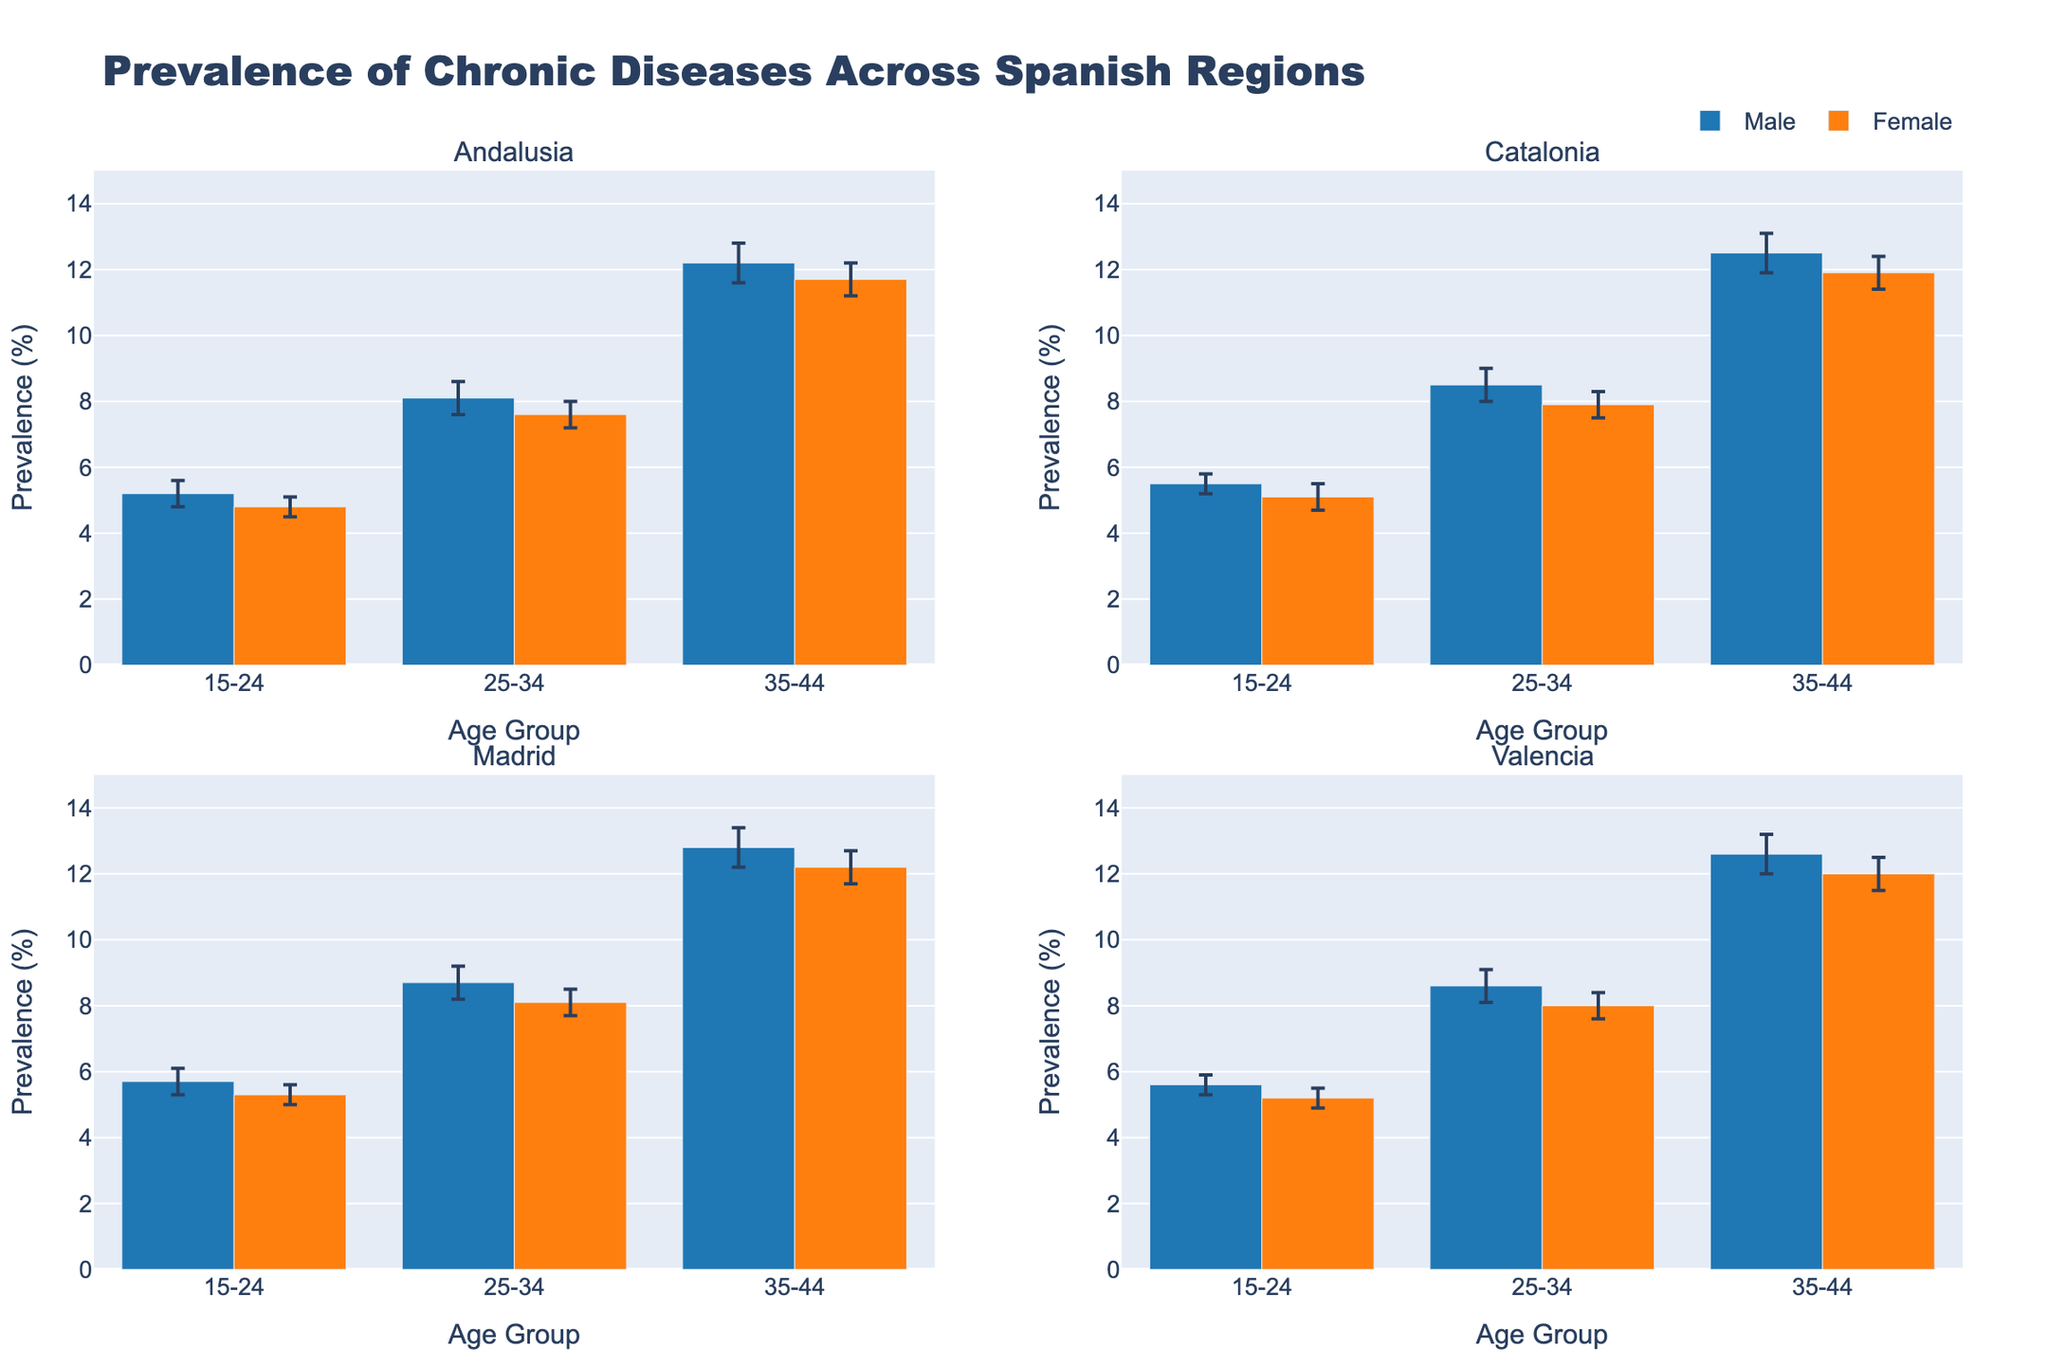What's the title of the figure? The title is displayed at the top center of the figure.
Answer: Prevalence of Chronic Diseases Across Spanish Regions Which age group has the highest prevalence of chronic diseases in Andalusia for males? We locate Andalusia in the top-left subplot, identify the blue bars, and see that the 35-44 age group has the highest value.
Answer: 35-44 What is the prevalence of chronic diseases for females aged 25-34 in Madrid? In the Madrid subplot (bottom-left), look for the orange bar corresponding to 25-34 age group and read its height.
Answer: 8.1% How does the prevalence of chronic diseases among males aged 15-24 in Catalonia compare to those in Valencia? Compare the heights of the blue bars for the 15-24 age group in the Catalonia (top-right) and Valencia (bottom-right) subplots.
Answer: Catalonia has a higher prevalence (5.5% vs. 5.6%) Which region has the smallest error bar for males aged 35-44? Look across all subplots at the blue bars for 35-44 age group and compare the lengths of the error bars.
Answer: All regions have the same error bar length (0.6%) What is the difference in chronic disease prevalence between males and females aged 35-44 in Valencia? In the Valencia subplot (bottom-right), subtract the height of the orange bar from the blue bar for the 35-44 age group.
Answer: 0.6% (12.6% - 12%) Which gender generally shows higher prevalence rates across age groups in any region? By inspecting the bar heights in all subplots, we observe whether blue (males) or orange (females) bars are generally taller.
Answer: Males In which region is the prevalence for females aged 25-34 higher than for males in the same age group? Check each subplot for the 25-34 age group to see if the orange bar is taller than the blue bar.
Answer: None Calculate the average prevalence of chronic diseases for all age groups in Catalonia for males. Add the heights of the blue bars in Catalonia subplot and divide by the number of age groups (3). (5.5 + 8.5 + 12.5) / 3
Answer: 8.83% Are the error bars for chronic disease prevalence consistent across regions for any age group? Check if the error bars heights are equal for a specific age group across all subplots.
Answer: Yes, for all age groups 